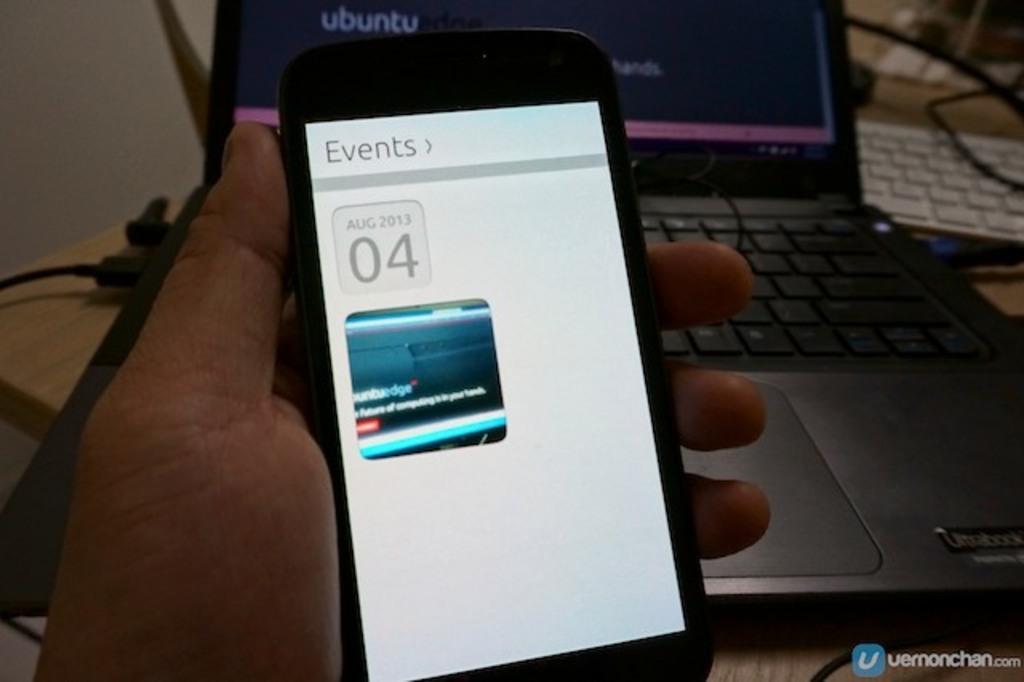Describe this image in one or two sentences. In this image I can see a person's hand holding a mobile which is black and white in color. In the background I can see a cream colored table and on it I can see a black colored laptop, a white colored keyboard and few black colored wires. 